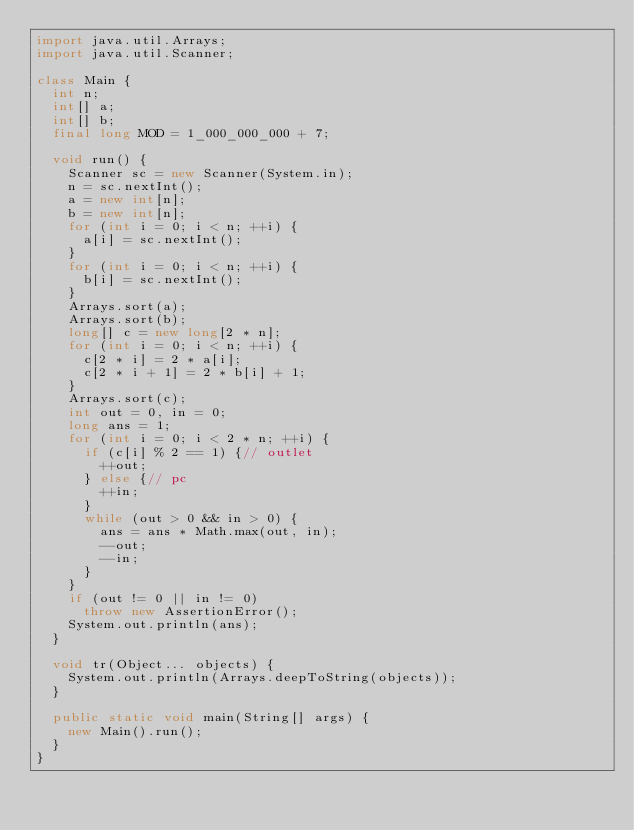Convert code to text. <code><loc_0><loc_0><loc_500><loc_500><_Java_>import java.util.Arrays;
import java.util.Scanner;

class Main {
	int n;
	int[] a;
	int[] b;
	final long MOD = 1_000_000_000 + 7;

	void run() {
		Scanner sc = new Scanner(System.in);
		n = sc.nextInt();
		a = new int[n];
		b = new int[n];
		for (int i = 0; i < n; ++i) {
			a[i] = sc.nextInt();
		}
		for (int i = 0; i < n; ++i) {
			b[i] = sc.nextInt();
		}
		Arrays.sort(a);
		Arrays.sort(b);
		long[] c = new long[2 * n];
		for (int i = 0; i < n; ++i) {
			c[2 * i] = 2 * a[i];
			c[2 * i + 1] = 2 * b[i] + 1;
		}
		Arrays.sort(c);
		int out = 0, in = 0;
		long ans = 1;
		for (int i = 0; i < 2 * n; ++i) {
			if (c[i] % 2 == 1) {// outlet
				++out;
			} else {// pc
				++in;
			}
			while (out > 0 && in > 0) {
				ans = ans * Math.max(out, in);
				--out;
				--in;
			}
		}
		if (out != 0 || in != 0)
			throw new AssertionError();
		System.out.println(ans);
	}

	void tr(Object... objects) {
		System.out.println(Arrays.deepToString(objects));
	}

	public static void main(String[] args) {
		new Main().run();
	}
}</code> 